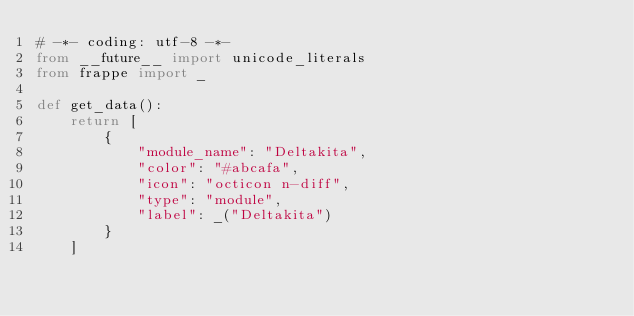<code> <loc_0><loc_0><loc_500><loc_500><_Python_># -*- coding: utf-8 -*-
from __future__ import unicode_literals
from frappe import _

def get_data():
	return [
		{
			"module_name": "Deltakita",
			"color": "#abcafa",
			"icon": "octicon n-diff",
			"type": "module",
			"label": _("Deltakita")
		}
	]
</code> 